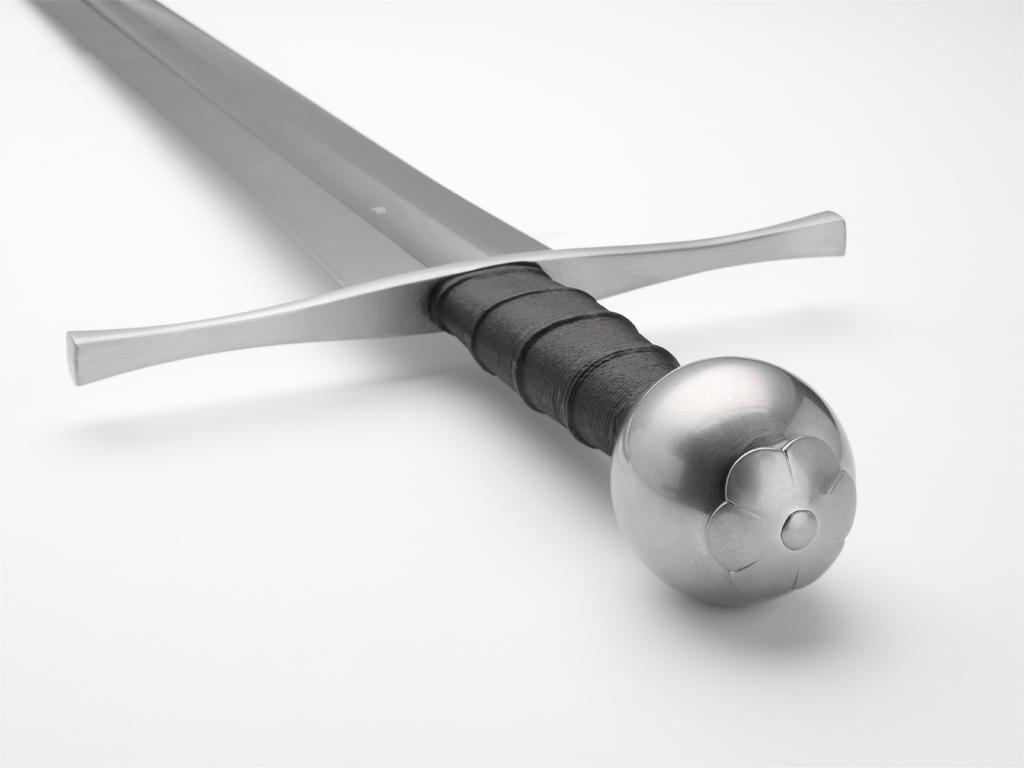What is the color of the surface in the image? The surface in the image is white. What object can be seen on the surface? There is a knife on the surface. Can you describe the appearance of the knife? The knife is ash, silver, and black in color. Where is the kettle located in the image? There is no kettle present in the image. What type of oil can be seen dripping from the knife in the image? There is no oil present in the image; the knife is simply described as having ash, silver, and black colors. 